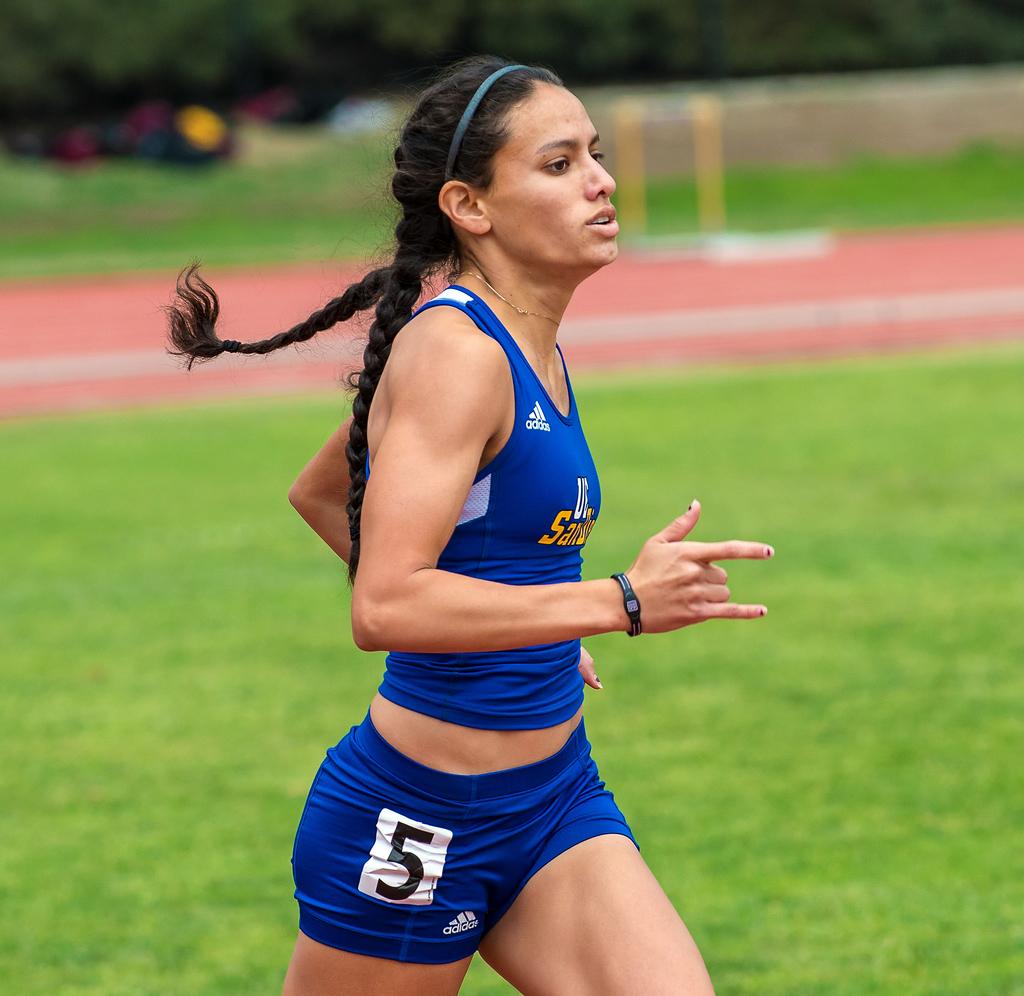What is the sponsor of the uniform?
Your answer should be very brief. Adidas. What is the player's number?
Provide a short and direct response. 5. 